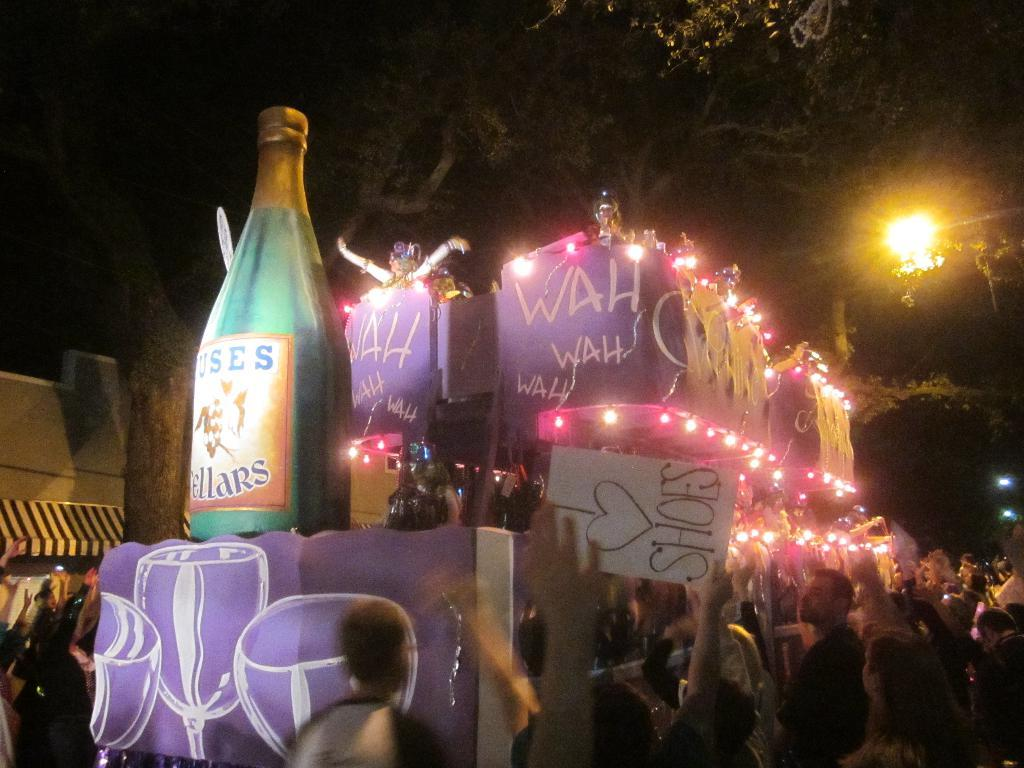<image>
Create a compact narrative representing the image presented. A crowd stands underneath a light at night with one person holding a sign that says I love Shoes 